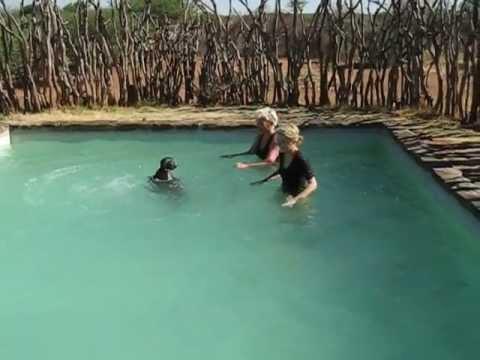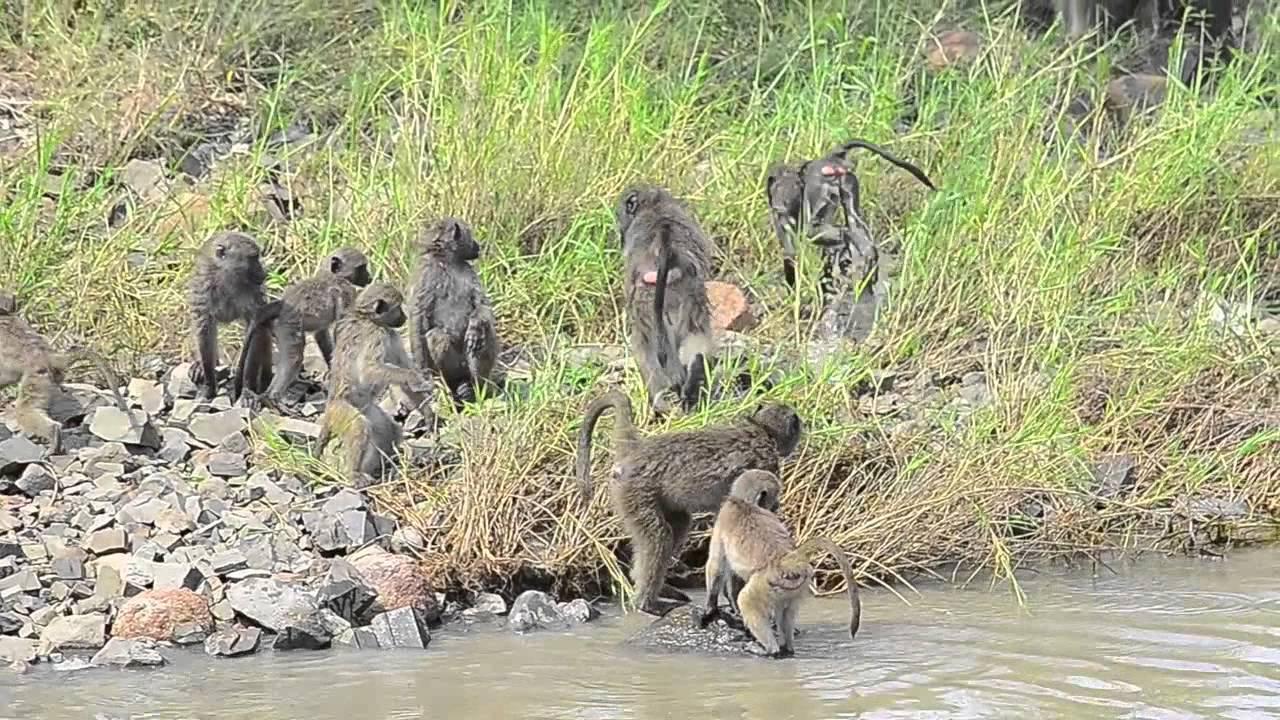The first image is the image on the left, the second image is the image on the right. For the images displayed, is the sentence "In one of the images, the pool is clearly man-made." factually correct? Answer yes or no. Yes. The first image is the image on the left, the second image is the image on the right. For the images shown, is this caption "There is a man-made swimming area with a square corner." true? Answer yes or no. Yes. 